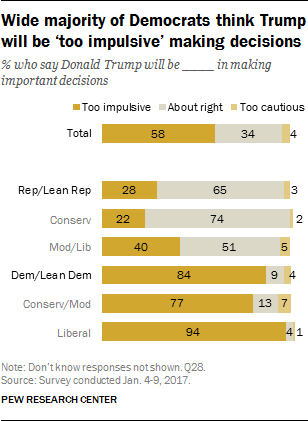Highlight a few significant elements in this photo. The ratio of the largest to smallest bar in the "Conserv/Mod" category is 11 to 1. A survey of Mod/Lib voters found that a significant portion believe that Donald Trump will be too cautious in making important decisions, with 5% of respondents answering in the affirmative. 